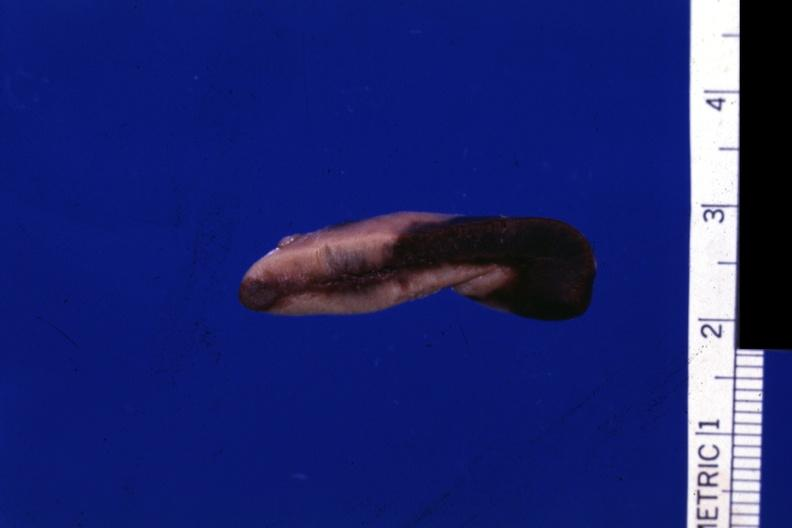where does this belong to?
Answer the question using a single word or phrase. Endocrine system 